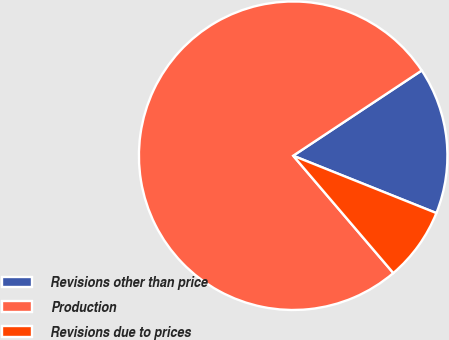Convert chart. <chart><loc_0><loc_0><loc_500><loc_500><pie_chart><fcel>Revisions other than price<fcel>Production<fcel>Revisions due to prices<nl><fcel>15.38%<fcel>76.92%<fcel>7.69%<nl></chart> 